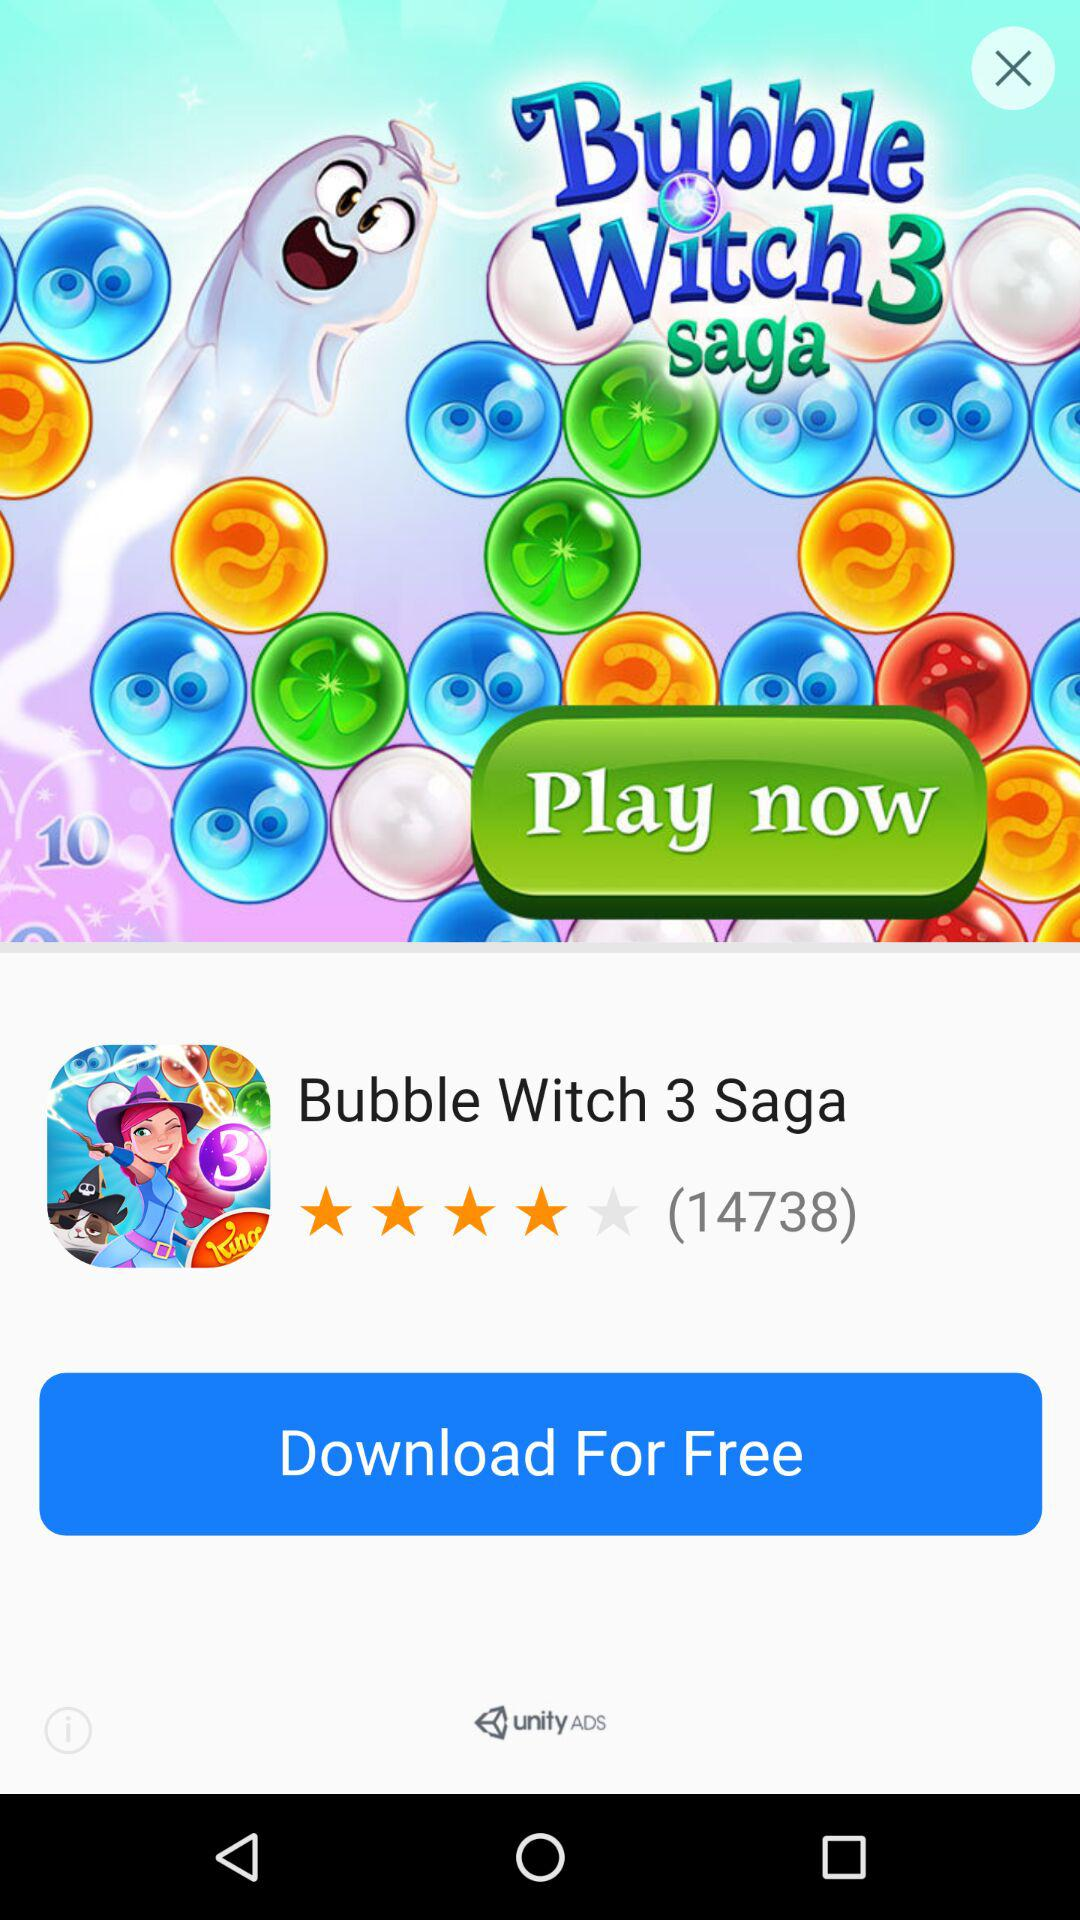What is the name of the game? The name of the game is "Bubble Witch 3 Saga". 